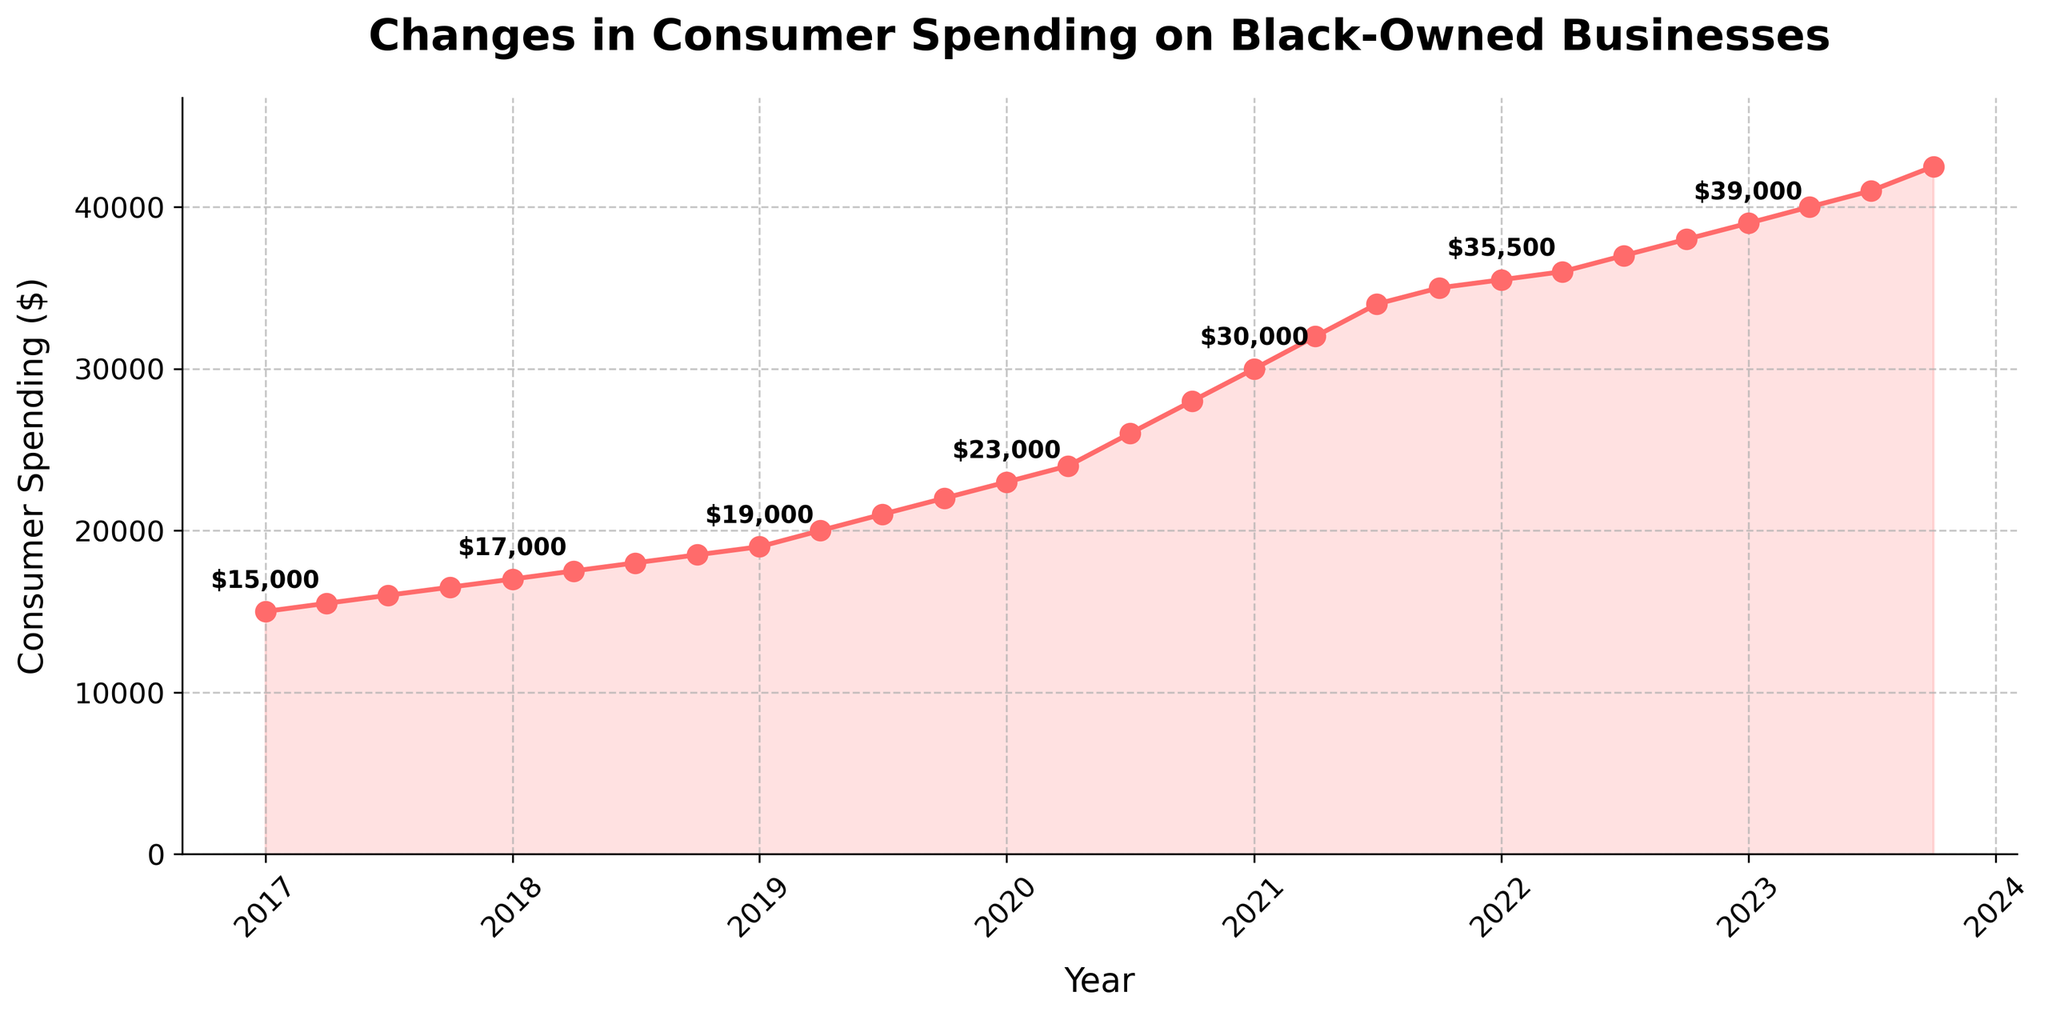What is the title of the plot? The title of the plot is given at the top of the figure.
Answer: Changes in Consumer Spending on Black-Owned Businesses What is the consumer spending amount in 2017-01-01? The data point for 2017-01-01 is shown as the first point on the time series plot.
Answer: $15,000 How much did consumer spending increase from 2017-01-01 to 2020-01-01? To find the increase, subtract the consumer spending for 2017-01-01 from that of 2020-01-01. The values are 23,000 and 15,000 respectively. 23,000 - 15,000 = 8,000
Answer: $8,000 Between which two consecutive points is the largest increase in consumer spending observed? By visually inspecting the plot, the steepest rise is between two points. The largest increase is between 2020-04-01 and 2020-07-01.
Answer: 2020-04-01 and 2020-07-01 How does the trend in consumer spending change from 2017 to 2023? By observing the overall direction of the plot from 2017 to 2023, consumer spending shows a consistent upward trend.
Answer: Consistently increasing From the plot, estimate the consumer spending in 2023-10-01 based on the annotated points. The point for 2023-10-01 is at the end of the plot line, and it is annotated.
Answer: $42,500 How much did consumer spending increase from 2020-01-01 to 2021-01-01? To find the increase, subtract the consumer spending for 2020-01-01 from that of 2021-01-01. The values are 30,000 and 23,000 respectively. 30,000 - 23,000 = 7,000
Answer: $7,000 What is the average consumer spending for the year 2021? To find the average, sum the values for the four quarters of 2021 and divide by 4. The values are 30,000, 32,000, 34,000, and 35,000. (30,000 + 32,000 + 34,000 + 35,000) / 4 = 32,750
Answer: $32,750 Can you identify any seasonality or periodic pattern in the consumer spending data? By examining the plot for repeating patterns or cyclical trends within a year or across years. There is no clear seasonality or periodic pattern.
Answer: No Which year appears to have the highest consumer spending growth? By comparing the vertical differences between points year-to-year. The year 2020 shows the most significant jump, notably between 2020-04-01 and 2020-07-01.
Answer: 2020 